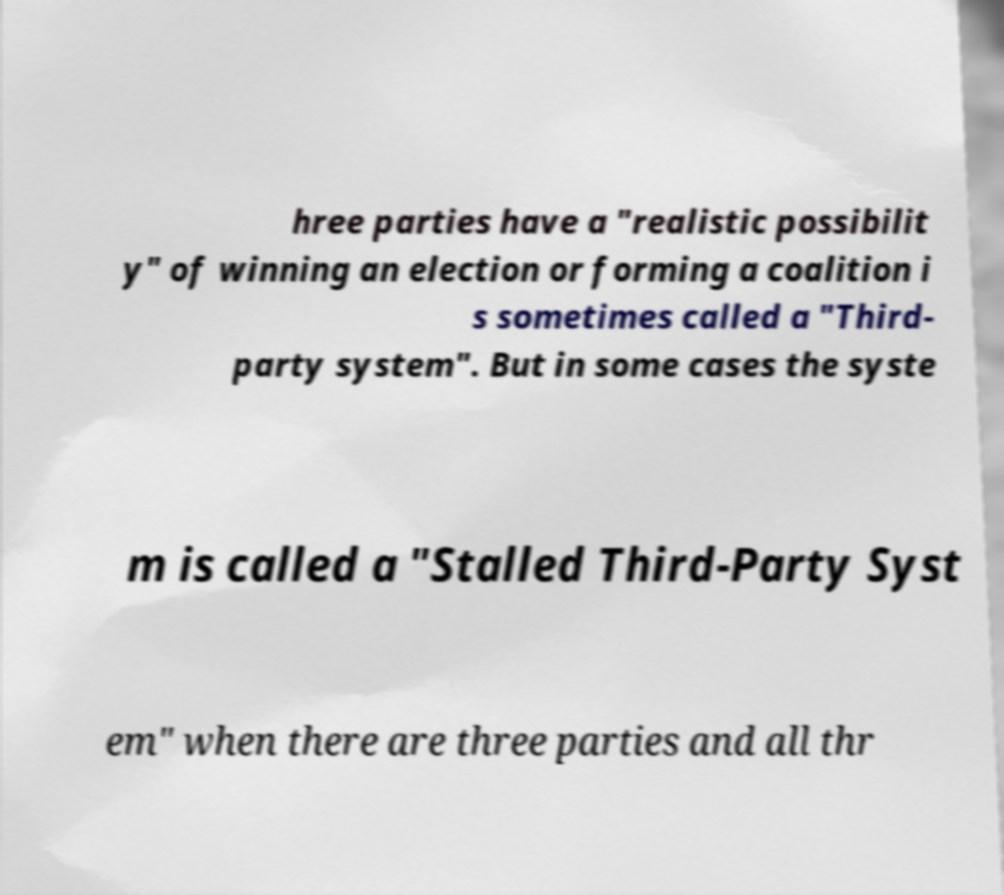Please read and relay the text visible in this image. What does it say? hree parties have a "realistic possibilit y" of winning an election or forming a coalition i s sometimes called a "Third- party system". But in some cases the syste m is called a "Stalled Third-Party Syst em" when there are three parties and all thr 